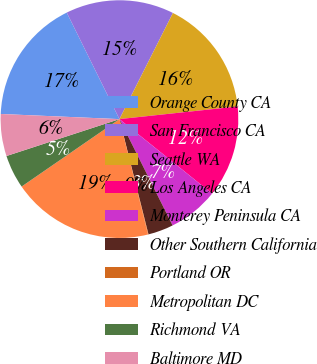<chart> <loc_0><loc_0><loc_500><loc_500><pie_chart><fcel>Orange County CA<fcel>San Francisco CA<fcel>Seattle WA<fcel>Los Angeles CA<fcel>Monterey Peninsula CA<fcel>Other Southern California<fcel>Portland OR<fcel>Metropolitan DC<fcel>Richmond VA<fcel>Baltimore MD<nl><fcel>17.0%<fcel>14.74%<fcel>15.87%<fcel>12.48%<fcel>6.84%<fcel>3.45%<fcel>0.06%<fcel>19.26%<fcel>4.58%<fcel>5.71%<nl></chart> 